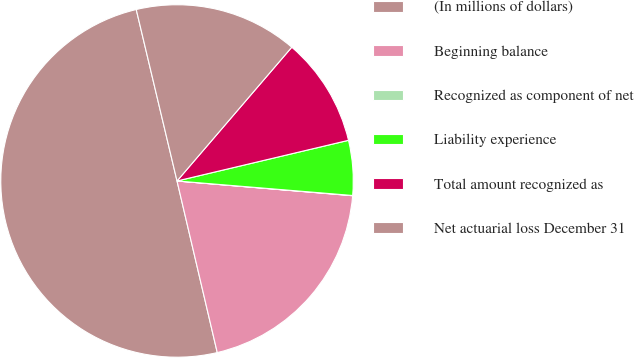Convert chart. <chart><loc_0><loc_0><loc_500><loc_500><pie_chart><fcel>(In millions of dollars)<fcel>Beginning balance<fcel>Recognized as component of net<fcel>Liability experience<fcel>Total amount recognized as<fcel>Net actuarial loss December 31<nl><fcel>49.95%<fcel>20.0%<fcel>0.02%<fcel>5.02%<fcel>10.01%<fcel>15.0%<nl></chart> 